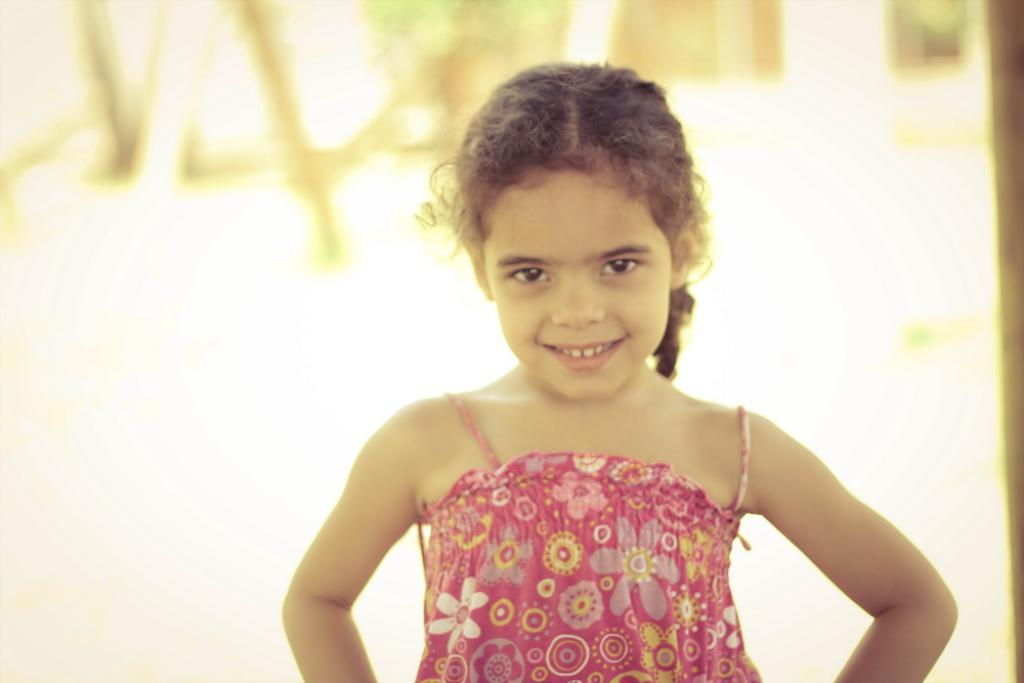Who is the main subject in the image? There is a girl in the image. What is the girl doing in the image? The girl is standing. What is the girl wearing in the image? The girl is wearing a pink dress. Can you describe the background of the image? The background of the image is blurred. How many pizzas are being served in the story depicted in the image? There are no pizzas or story depicted in the image; it features a girl standing in a blurred background. What type of plough is being used by the girl in the image? There is no plough present in the image; the girl is wearing a pink dress and standing in a blurred background. 